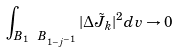<formula> <loc_0><loc_0><loc_500><loc_500>\int _ { B _ { 1 } \ B _ { 1 - j ^ { - 1 } } } | \Delta \tilde { J } _ { k } | ^ { 2 } d v \rightarrow 0</formula> 